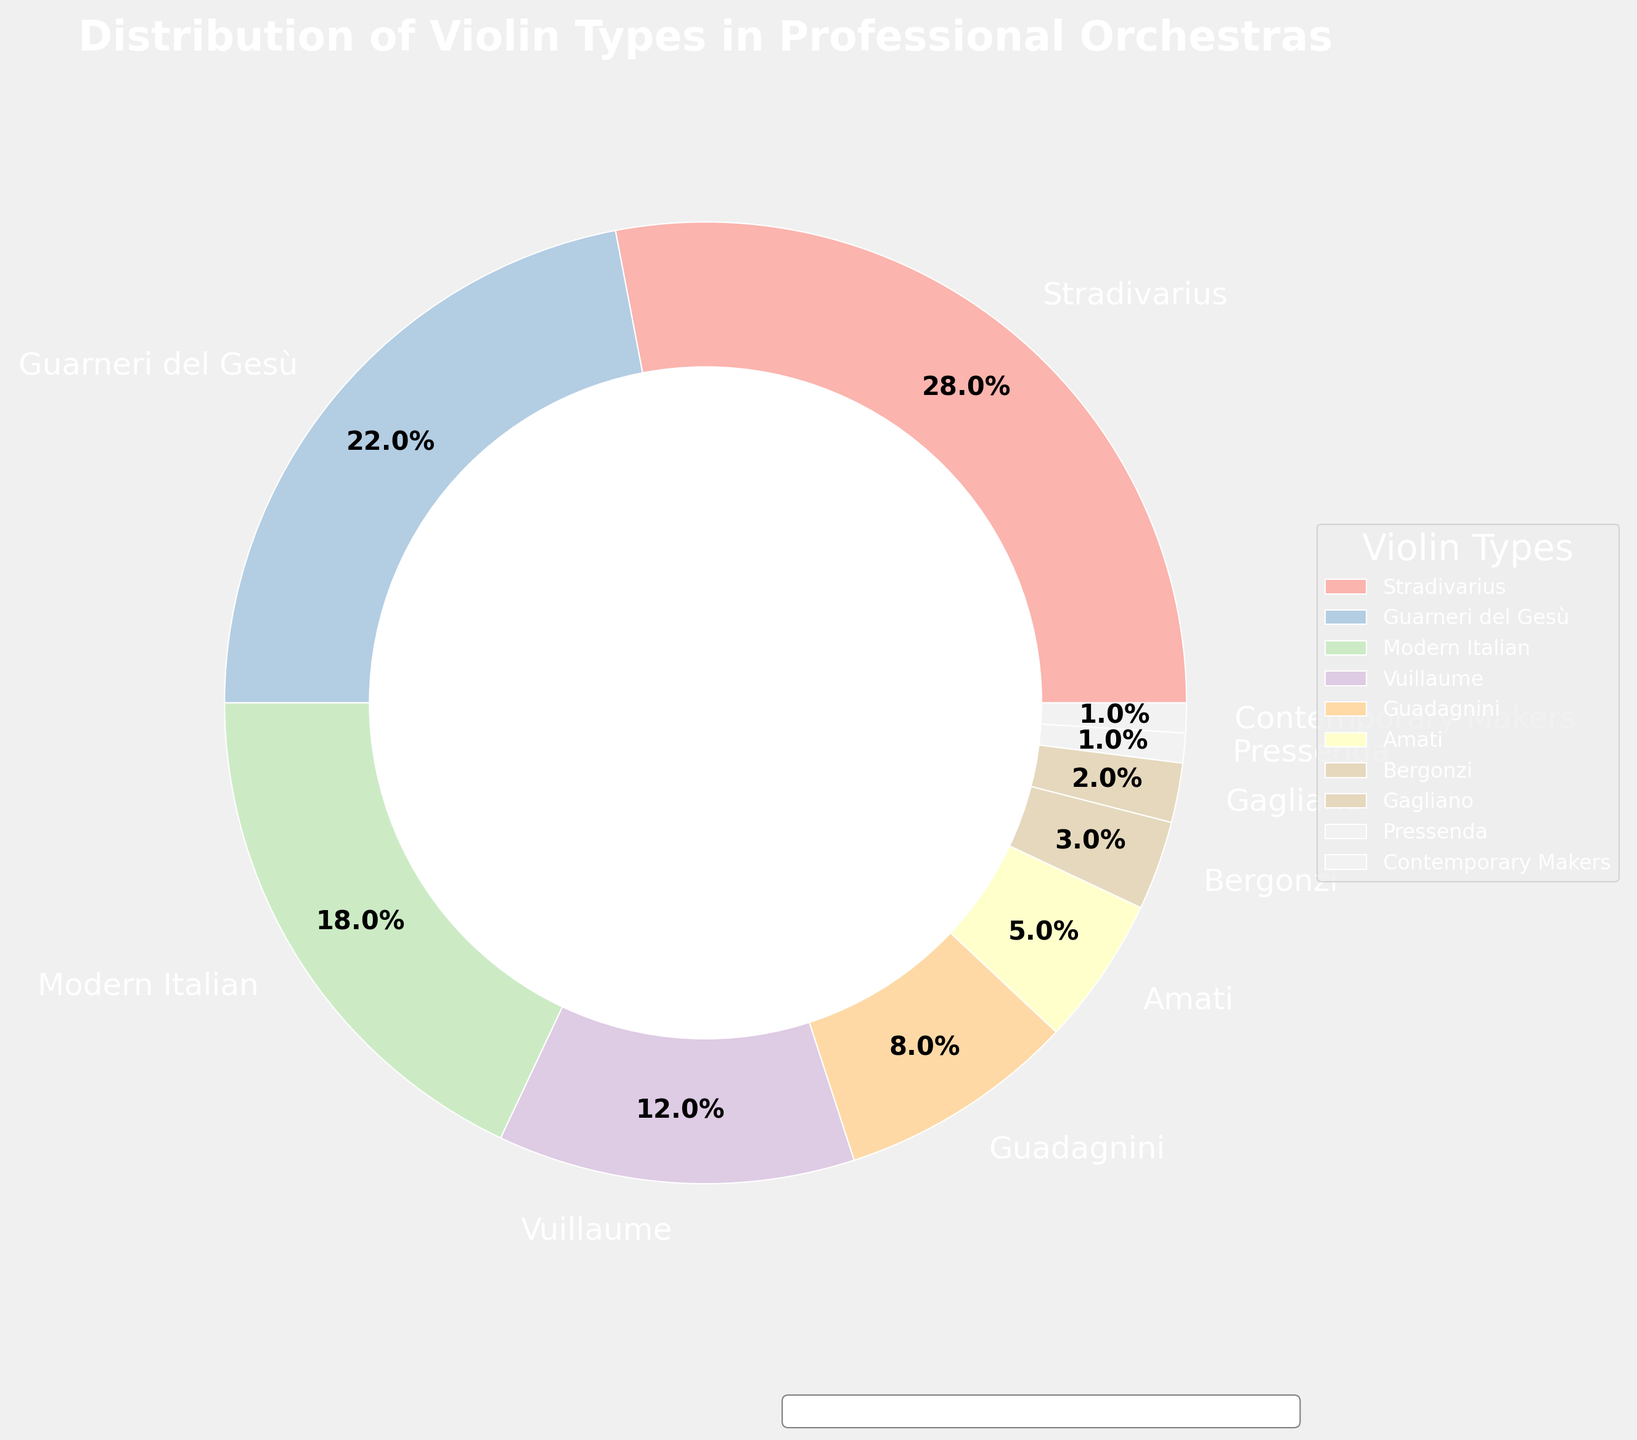what percentage of violins in professional orchestras are Stradivarius? Stradivarius violins make up a specific portion of the pie chart. By looking at the pie slice labeled 'Stradivarius,' we can see that it occupies 28% of the chart.
Answer: 28% Which two violin types are used the least in professional orchestras? We identify the smallest slices in the pie chart. The slices labeled 'Pressenda' and 'Contemporary Makers' are the smallest, both at 1%.
Answer: Pressenda and Contemporary Makers How much larger is the percentage of Stradivarius violins compared to Vuillaume violins? To find the difference, subtract the percentage of Vuillaume from Stradivarius: 28% - 12% = 16%.
Answer: 16% What violin types make up over 20% of the total in professional orchestras? Slices that take up a portion over 20% are labeled accordingly. Only 'Stradivarius' (28%) and 'Guarneri del Gesù' (22%) exceed the 20% mark.
Answer: Stradivarius and Guarneri del Gesù What is the combined percentage of Guadagnini and Amati violins? Adding the percentages for 'Guadagnini' (8%) and 'Amati' (5%): 8% + 5% = 13%.
Answer: 13% By how much does the percentage of Guarneri del Gesù violins exceed that of Modern Italian violins? Subtract the percentage of Modern Italian from Guarneri del Gesù: 22% - 18% = 4%.
Answer: 4% What visual features are used to differentiate the violin types in the pie chart? The pie chart uses different colors to represent each violin type, labels, percentage values for each slice, and a legend listing the violin types.
Answer: Colors, labels, percentage values, and legend Compare the percentage of Bergonzi and Gagliano violins in professional orchestras. Which is greater and by how much? Bergonzi is at 3% and Gagliano at 2%. The difference is 3% - 2% = 1%, and Bergonzi is greater.
Answer: Bergonzi, by 1% What is the average percentage of usage for Guarneri del Gesù and Modern Italian violins? Adding the percentages and dividing by 2: (22% + 18%) / 2 = 20%.
Answer: 20% How many violin types constitute less than 10% each of the total? Identifying slices below 10%: Vuillaume (12% is more), Guadagnini (8%), Amati (5%), Bergonzi (3%), Gagliano (2%), Pressenda (1%), Contemporary Makers (1%). Six types are below 10%.
Answer: 6 